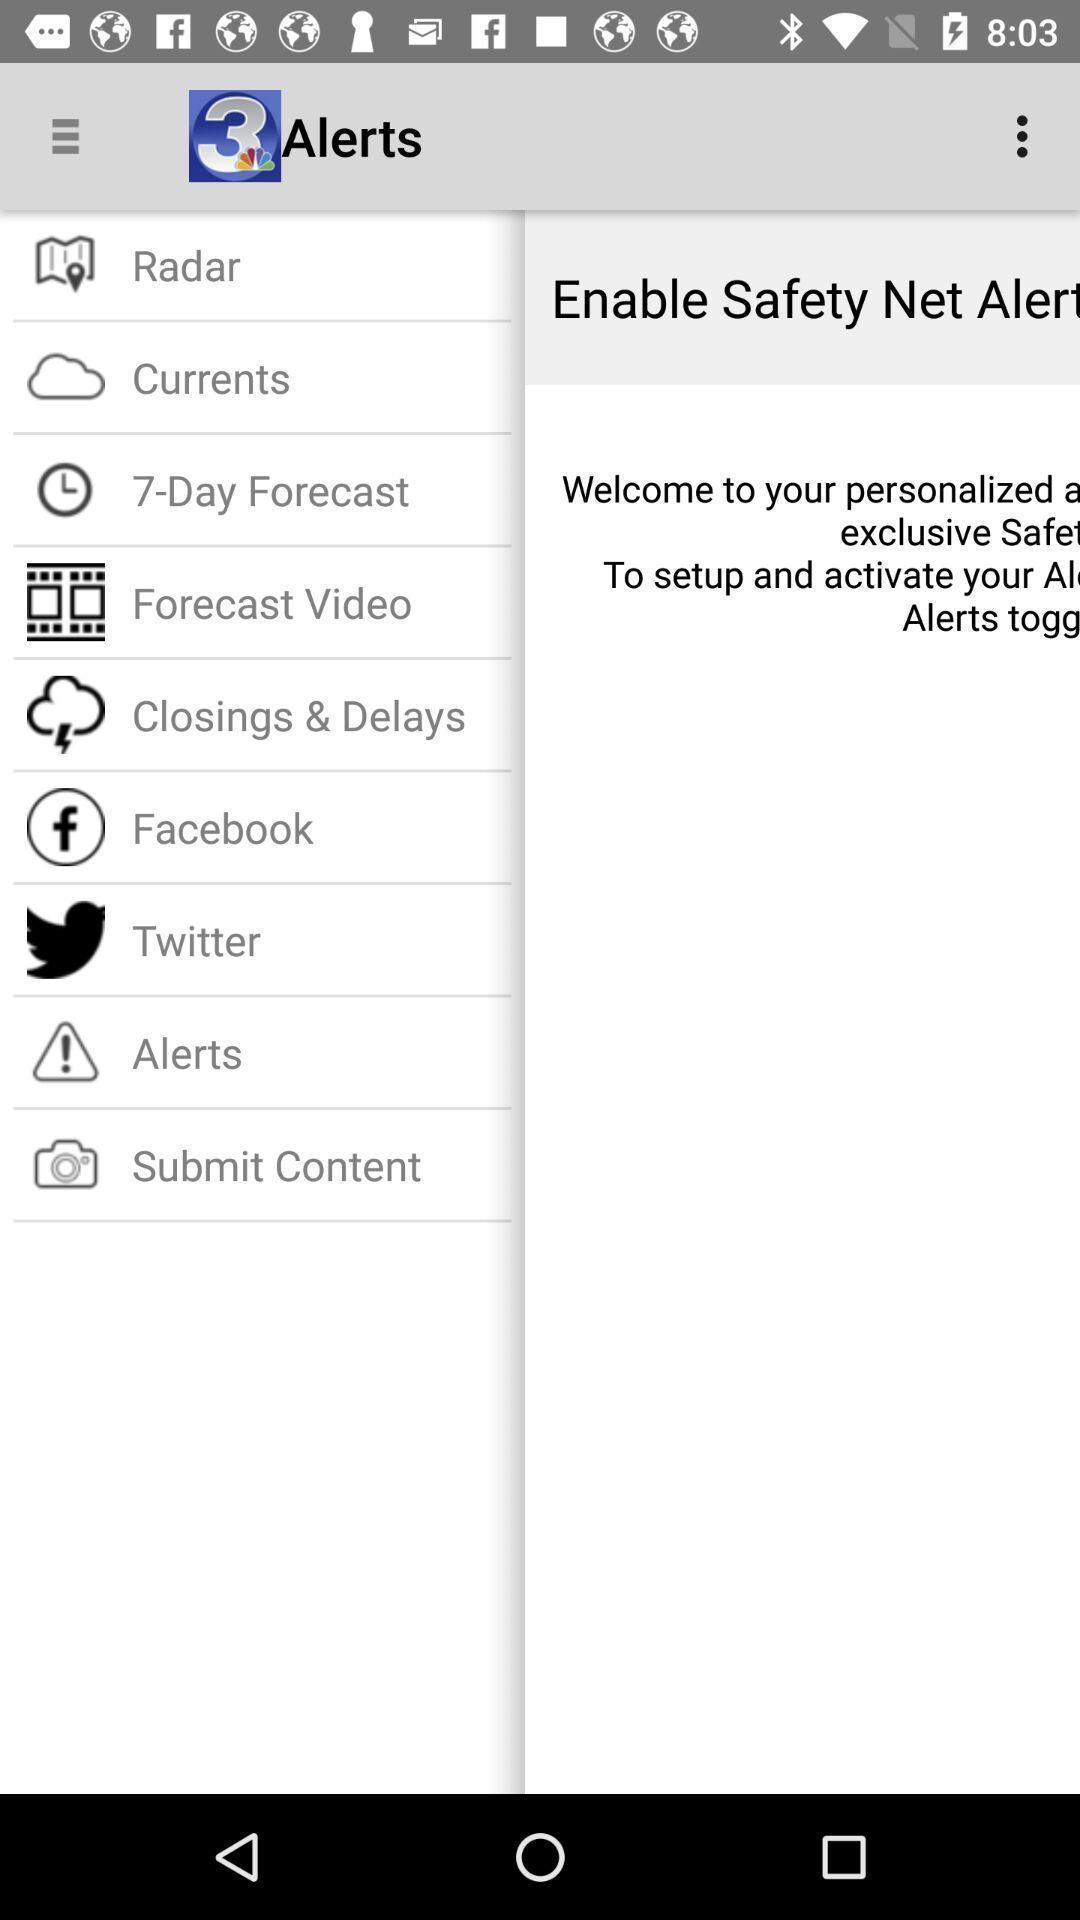Provide a detailed account of this screenshot. Page displaying with list of options. 